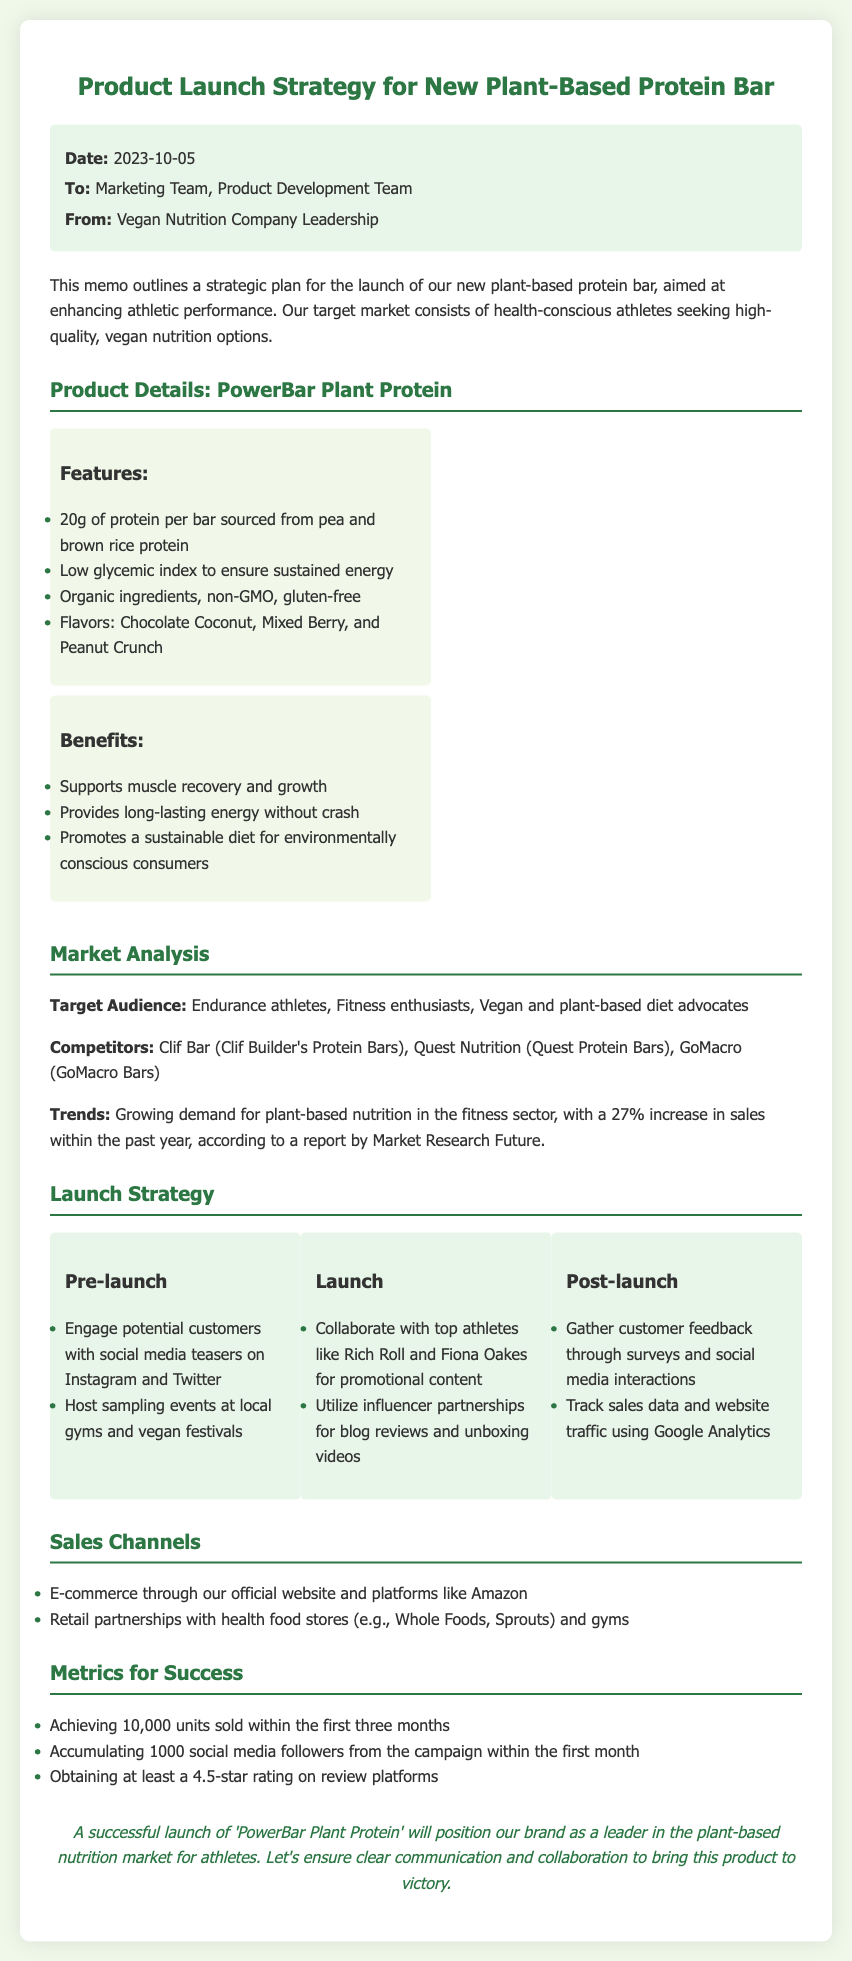what is the product name? The product name is stated in the document as "PowerBar Plant Protein."
Answer: PowerBar Plant Protein what is the target audience? The target audience section lists "Endurance athletes, Fitness enthusiasts, Vegan and plant-based diet advocates."
Answer: Endurance athletes, Fitness enthusiasts, Vegan and plant-based diet advocates how many grams of protein are in each bar? The document specifies that each bar contains "20g of protein."
Answer: 20g what are the flavors of the product? The flavors of the protein bar are listed as "Chocolate Coconut, Mixed Berry, and Peanut Crunch."
Answer: Chocolate Coconut, Mixed Berry, Peanut Crunch who are the athletes mentioned for promotional content? The memo mentions "Rich Roll and Fiona Oakes" for promotional content.
Answer: Rich Roll and Fiona Oakes what percentage increase in sales for plant-based nutrition is mentioned? The report states a "27% increase in sales" for the past year.
Answer: 27% what is a key benefit of the protein bar? One benefit mentioned is that it "supports muscle recovery and growth."
Answer: Supports muscle recovery and growth what is one channel for sales mentioned? The document mentions "E-commerce through our official website and platforms like Amazon" as a sales channel.
Answer: E-commerce through our official website and platforms like Amazon what is the goal for units sold in the first three months? The memo specifies the goal is "10,000 units sold within the first three months."
Answer: 10,000 units sold within the first three months 